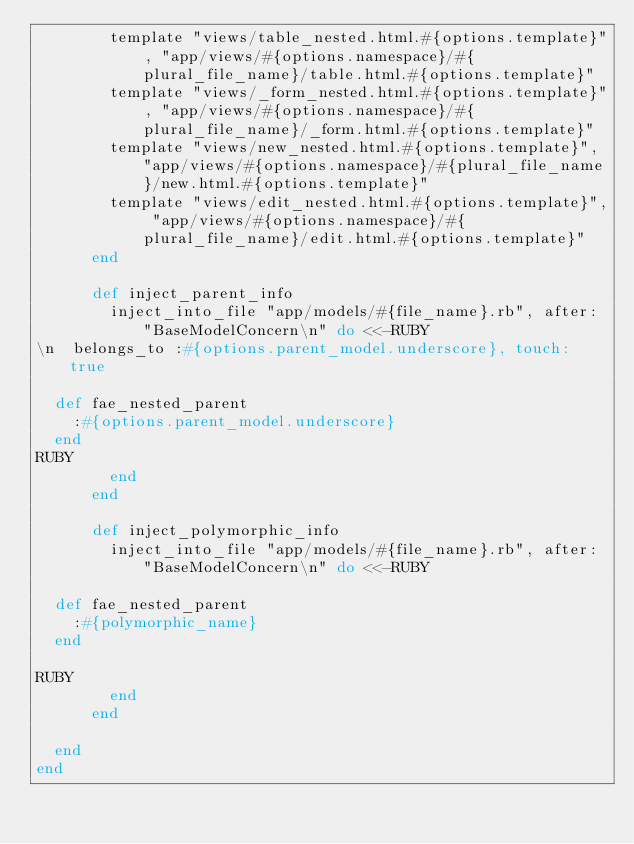<code> <loc_0><loc_0><loc_500><loc_500><_Ruby_>        template "views/table_nested.html.#{options.template}", "app/views/#{options.namespace}/#{plural_file_name}/table.html.#{options.template}"
        template "views/_form_nested.html.#{options.template}", "app/views/#{options.namespace}/#{plural_file_name}/_form.html.#{options.template}"
        template "views/new_nested.html.#{options.template}", "app/views/#{options.namespace}/#{plural_file_name}/new.html.#{options.template}"
        template "views/edit_nested.html.#{options.template}", "app/views/#{options.namespace}/#{plural_file_name}/edit.html.#{options.template}"
      end

      def inject_parent_info
        inject_into_file "app/models/#{file_name}.rb", after: "BaseModelConcern\n" do <<-RUBY
\n  belongs_to :#{options.parent_model.underscore}, touch: true

  def fae_nested_parent
    :#{options.parent_model.underscore}
  end
RUBY
        end
      end

      def inject_polymorphic_info
        inject_into_file "app/models/#{file_name}.rb", after: "BaseModelConcern\n" do <<-RUBY

  def fae_nested_parent
    :#{polymorphic_name}
  end

RUBY
        end
      end

  end
end
</code> 